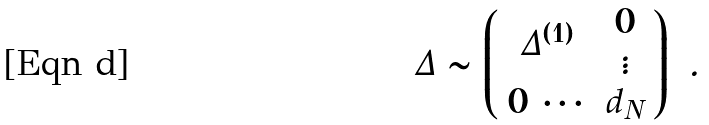<formula> <loc_0><loc_0><loc_500><loc_500>\Delta \sim \left ( \begin{array} { c c } \Delta ^ { ( 1 ) } & \begin{array} { c } 0 \\ \vdots \end{array} \\ 0 \, \cdots & d _ { N } \end{array} \right ) \ .</formula> 